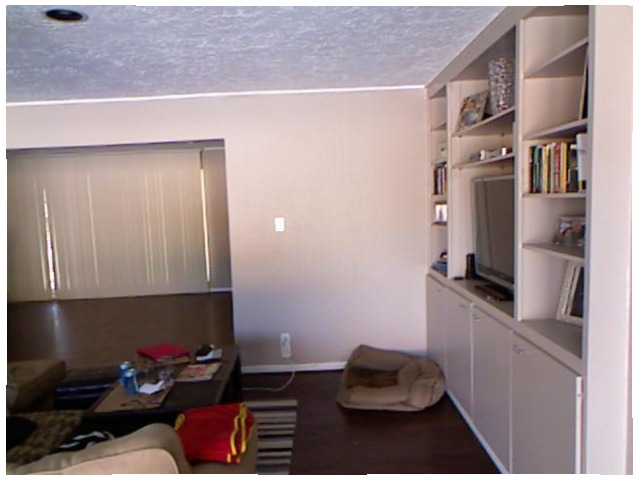<image>
Is the wire in the wall? No. The wire is not contained within the wall. These objects have a different spatial relationship. 